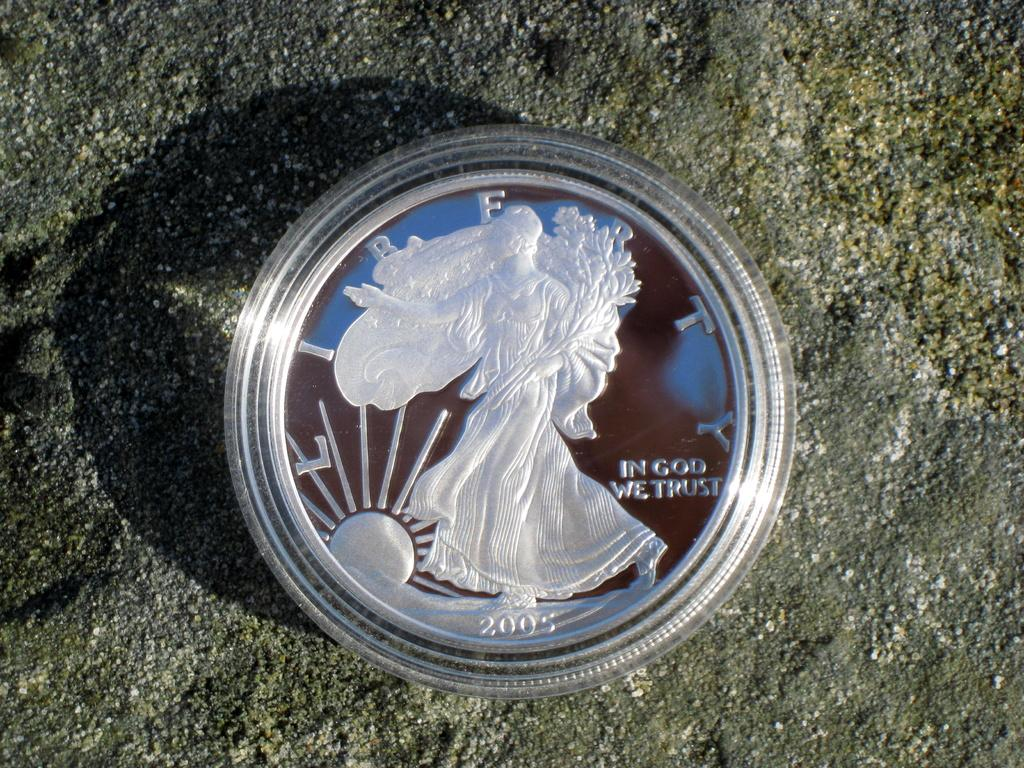What object can be seen in the image? There is a coin in the image. Where is the coin located? The coin is on the wall. What features are present on the coin? The coin has text and images on it. How does the coin affect the nerve system in the image? The coin does not affect the nerve system in the image, as it is an inanimate object. 